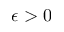<formula> <loc_0><loc_0><loc_500><loc_500>\epsilon > 0</formula> 